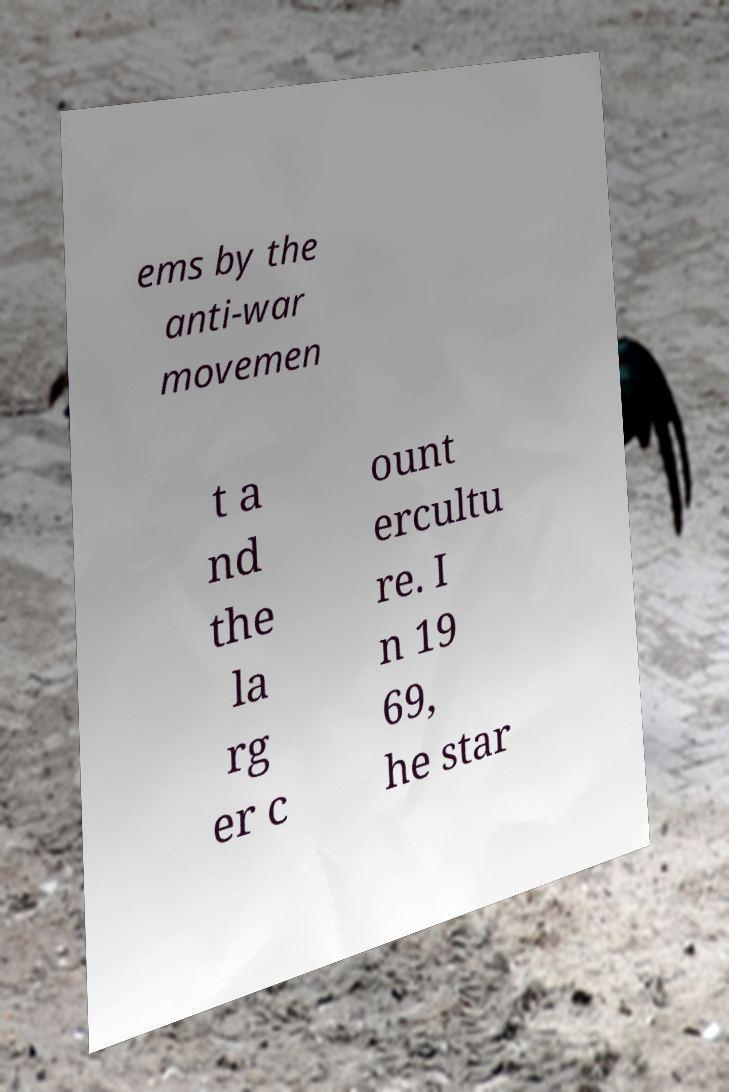There's text embedded in this image that I need extracted. Can you transcribe it verbatim? ems by the anti-war movemen t a nd the la rg er c ount ercultu re. I n 19 69, he star 